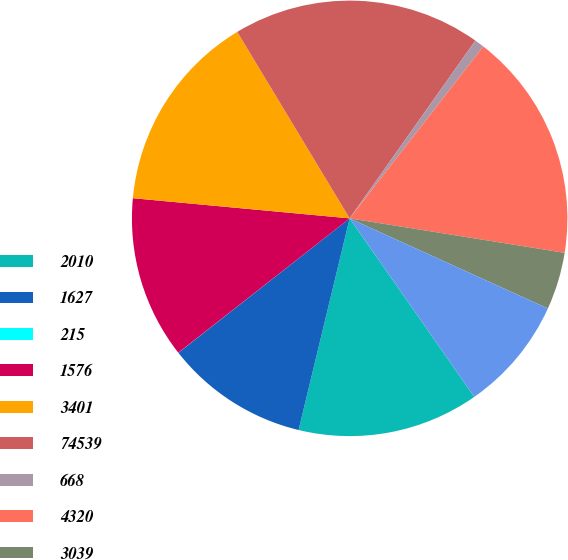Convert chart to OTSL. <chart><loc_0><loc_0><loc_500><loc_500><pie_chart><fcel>2010<fcel>1627<fcel>215<fcel>1576<fcel>3401<fcel>74539<fcel>668<fcel>4320<fcel>3039<fcel>1595<nl><fcel>13.47%<fcel>10.64%<fcel>0.01%<fcel>12.06%<fcel>14.89%<fcel>18.43%<fcel>0.72%<fcel>17.02%<fcel>4.26%<fcel>8.51%<nl></chart> 